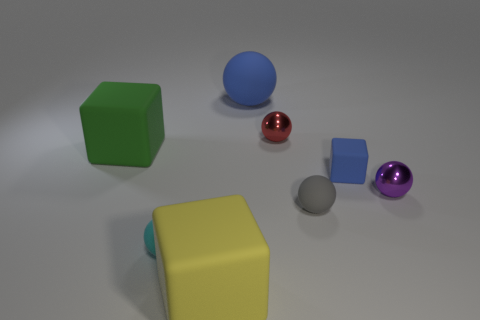Subtract all red spheres. How many spheres are left? 4 Subtract all big blue balls. How many balls are left? 4 Subtract all green spheres. Subtract all yellow blocks. How many spheres are left? 5 Add 1 cyan matte spheres. How many objects exist? 9 Subtract all balls. How many objects are left? 3 Add 6 small rubber spheres. How many small rubber spheres are left? 8 Add 1 large gray rubber blocks. How many large gray rubber blocks exist? 1 Subtract 0 yellow cylinders. How many objects are left? 8 Subtract all big gray shiny spheres. Subtract all red shiny objects. How many objects are left? 7 